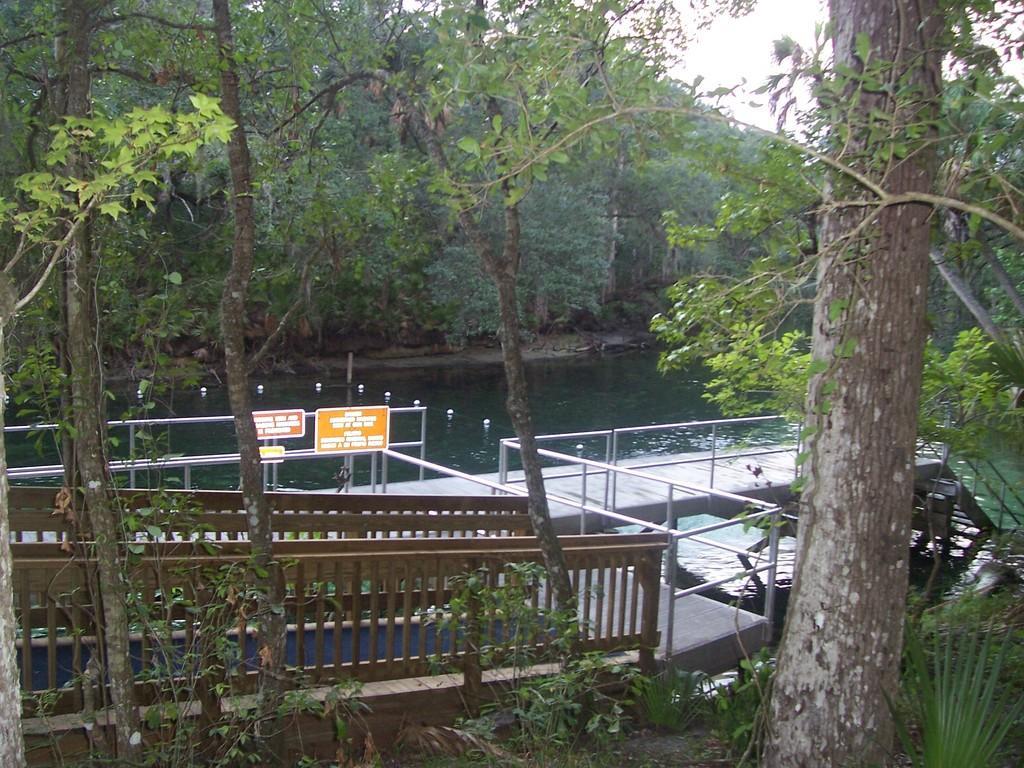Could you give a brief overview of what you see in this image? In this image I can see the lake ,tree,and bridge and sign boards and the sky visible. 